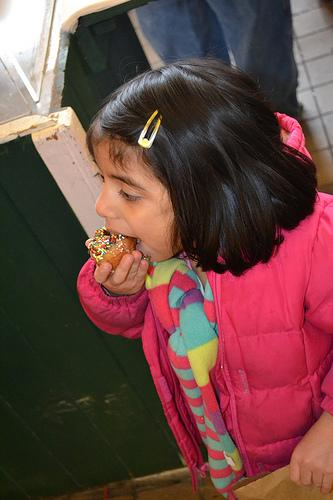At what time of the day is the girl consuming her treat? The girl is eating the donut as her first meal of the day. What is the color and texture of the girl's hair? The girl has dark brown, shiny, and shoulder-length hair. Describe the floor in the image. The floor has white tiles with black grout. What kind of wall is the girl standing next to? The girl is standing next to a green wall. Can you identify the color of the girl's coat in the image? The girl is wearing a bright pink coat. Explain the girl's winter outfit and its colors. The girl is wearing a puffy pink cold-weather coat and a colorful striped scarf that compliments the coat. Describe the hair accessory that the girl has in her hair. The girl has a gold barrette in her dark brown hair. Tell me something unique about the girl's facial features. The girl has thick and full eyebrows and brown eyes. What is the girl eating in the image? The girl is eating a donut with multicolored sprinkles. Mention any other person present in the image and their appearance. There is a person wearing blue jeans standing behind the girl. Identify the blue umbrella hanging on the wall. No, it's not mentioned in the image. What's the main element of the floor in the image? White tile with black grout In the image, what is the girl eating? A donut Examine the image and describe the girl's hair accessory. A gold hair barrette Based on the image, which options best describe the girl's coat and scarf? A) black coat and white scarf, B) pink coat and striped scarf, C) blue coat and polka dot scarf B) pink coat and striped scarf Identify three most dominant colors of the scarf that the young girl is wearing in the photo. Red, blue, and yellow Describe the wall behind the girl in the photo. A green wall with white trim. Based on the image, write a detailed and creative caption. A young girl enjoys her first meal of the day, a colorful donut with sprinkles, while wearing a bright pink coat and a vibrant striped scarf that perfectly complements her outfit. What is the girl wearing around her neck in the image? A colorful striped scarf What kind of donut is the young girl eating? A cake donut with multicolored sprinkles Look at the given image and describe the girl's expression. She is enjoying eating the donut. 